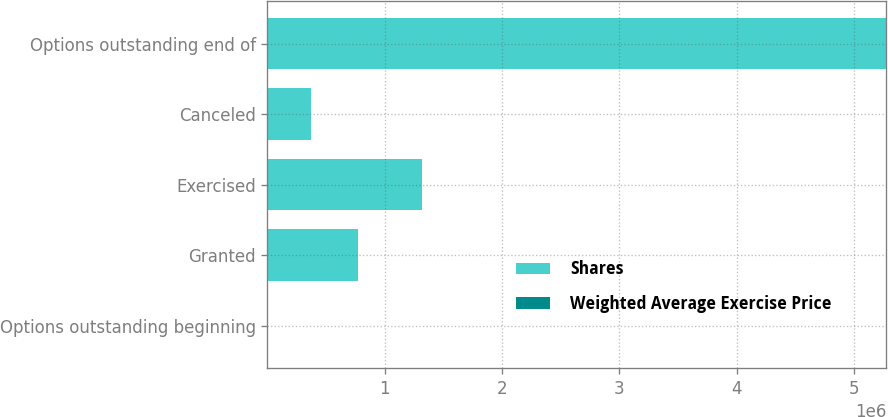Convert chart to OTSL. <chart><loc_0><loc_0><loc_500><loc_500><stacked_bar_chart><ecel><fcel>Options outstanding beginning<fcel>Granted<fcel>Exercised<fcel>Canceled<fcel>Options outstanding end of<nl><fcel>Shares<fcel>26.41<fcel>775500<fcel>1.31574e+06<fcel>369202<fcel>5.27357e+06<nl><fcel>Weighted Average Exercise Price<fcel>11.78<fcel>26.41<fcel>3.7<fcel>14.07<fcel>15.79<nl></chart> 